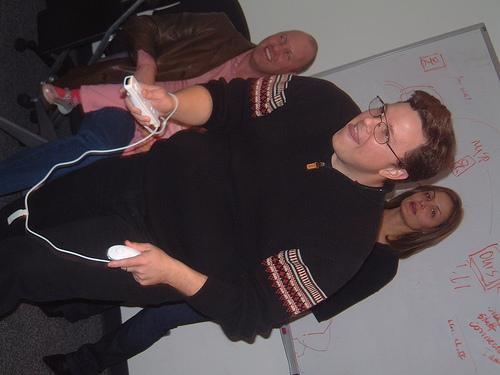How many players are there?

Choices:
A) two
B) one
C) three
D) four one 